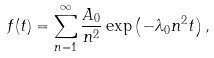Convert formula to latex. <formula><loc_0><loc_0><loc_500><loc_500>f ( t ) = \sum _ { n = 1 } ^ { \infty } \frac { A _ { 0 } } { n ^ { 2 } } \exp \left ( - \lambda _ { 0 } n ^ { 2 } t \right ) ,</formula> 